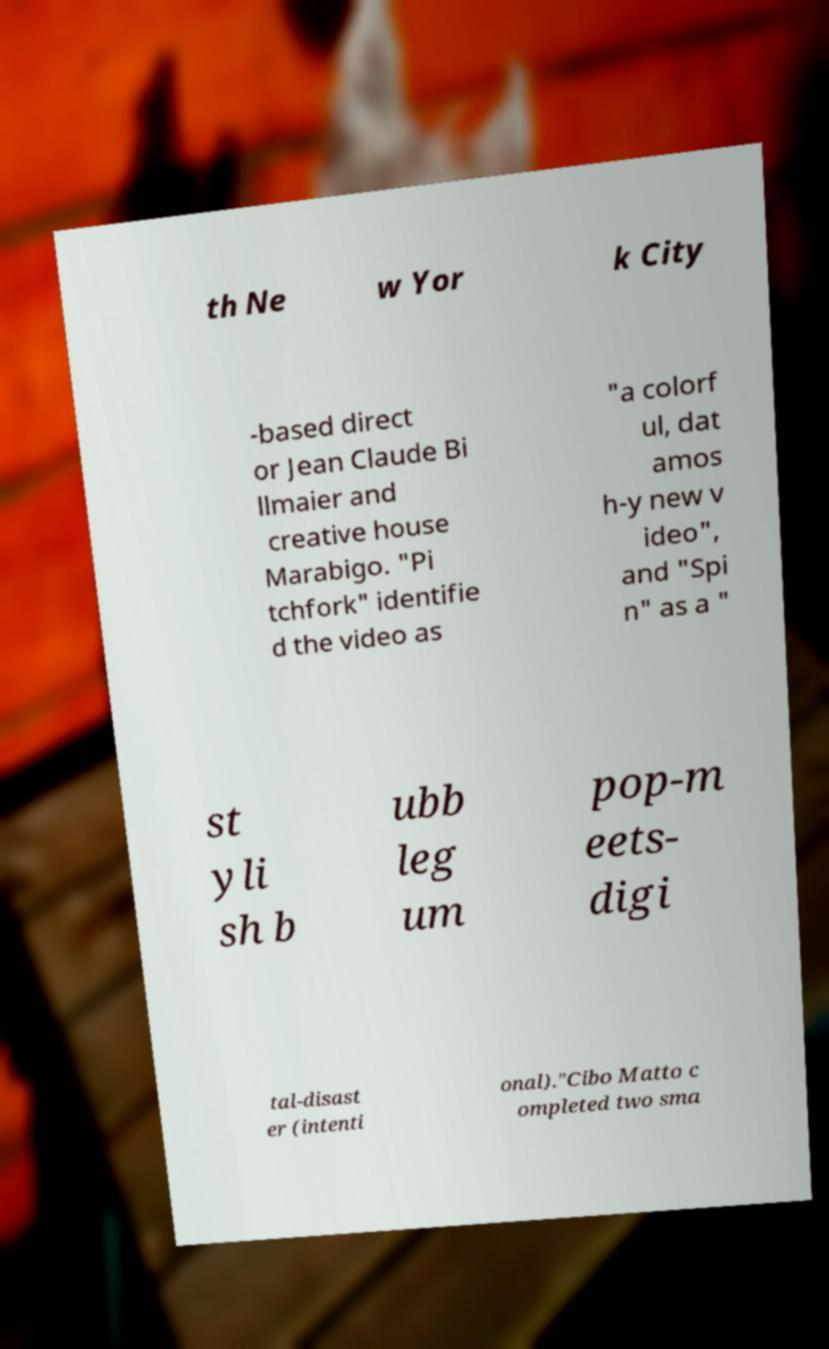Could you assist in decoding the text presented in this image and type it out clearly? th Ne w Yor k City -based direct or Jean Claude Bi llmaier and creative house Marabigo. "Pi tchfork" identifie d the video as "a colorf ul, dat amos h-y new v ideo", and "Spi n" as a " st yli sh b ubb leg um pop-m eets- digi tal-disast er (intenti onal)."Cibo Matto c ompleted two sma 